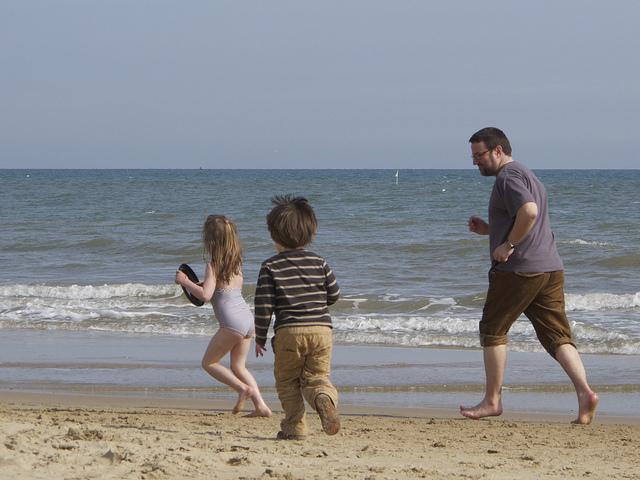How many people are holding a frisbee?
Give a very brief answer. 1. How many people can you see?
Give a very brief answer. 3. 